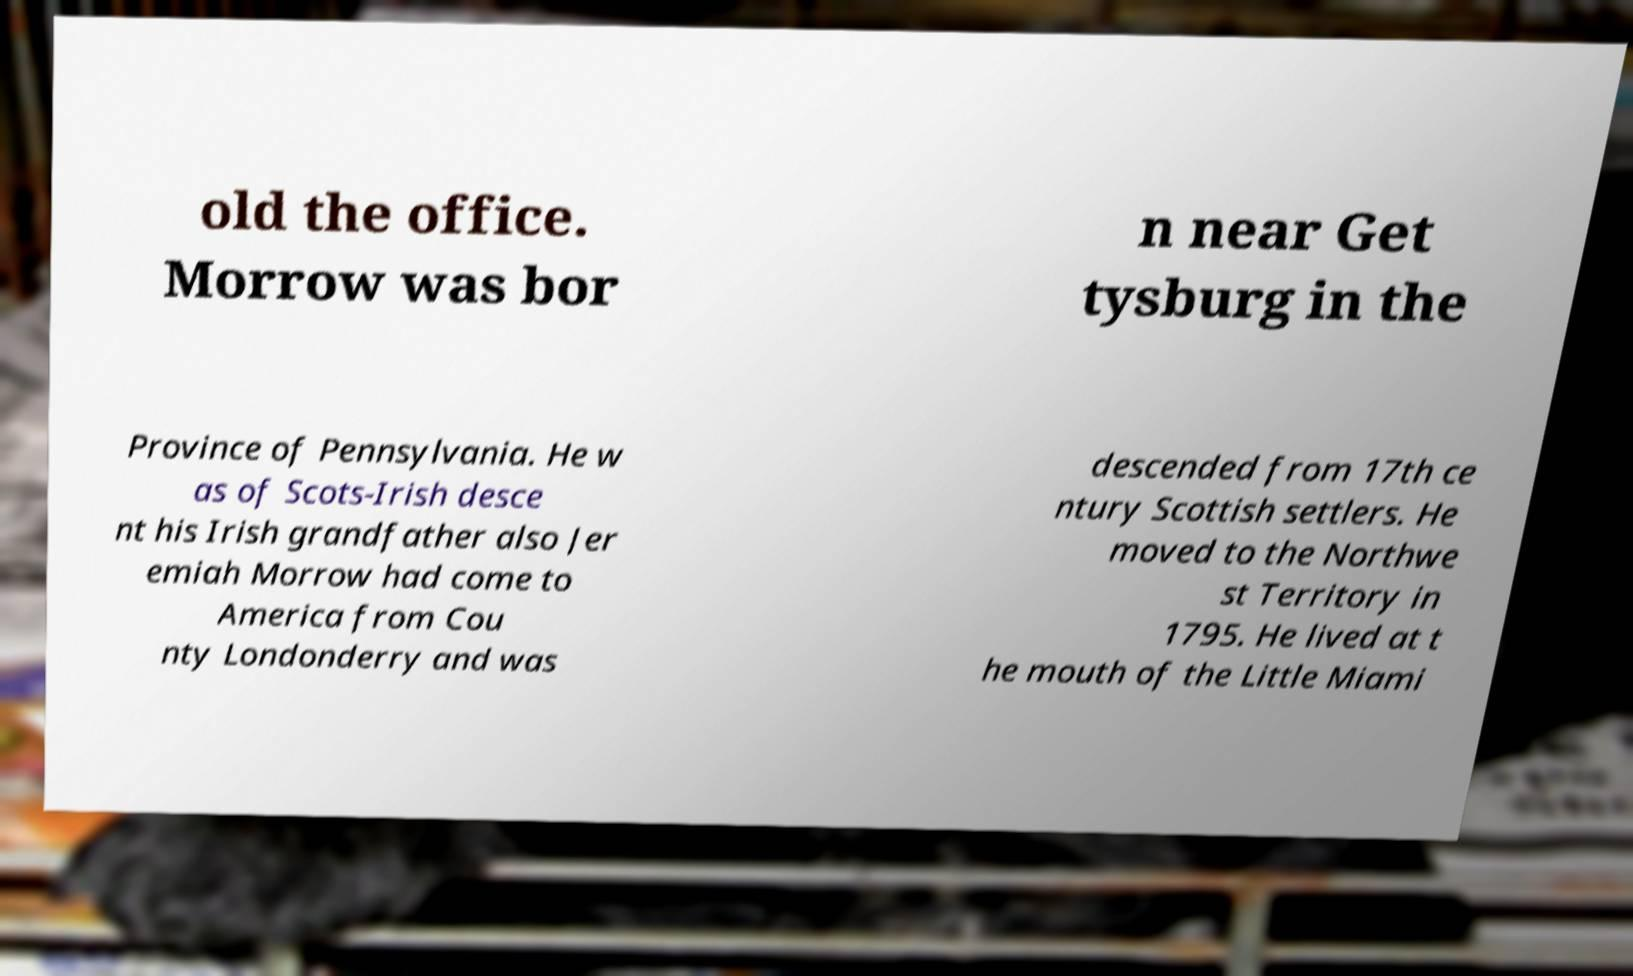There's text embedded in this image that I need extracted. Can you transcribe it verbatim? old the office. Morrow was bor n near Get tysburg in the Province of Pennsylvania. He w as of Scots-Irish desce nt his Irish grandfather also Jer emiah Morrow had come to America from Cou nty Londonderry and was descended from 17th ce ntury Scottish settlers. He moved to the Northwe st Territory in 1795. He lived at t he mouth of the Little Miami 